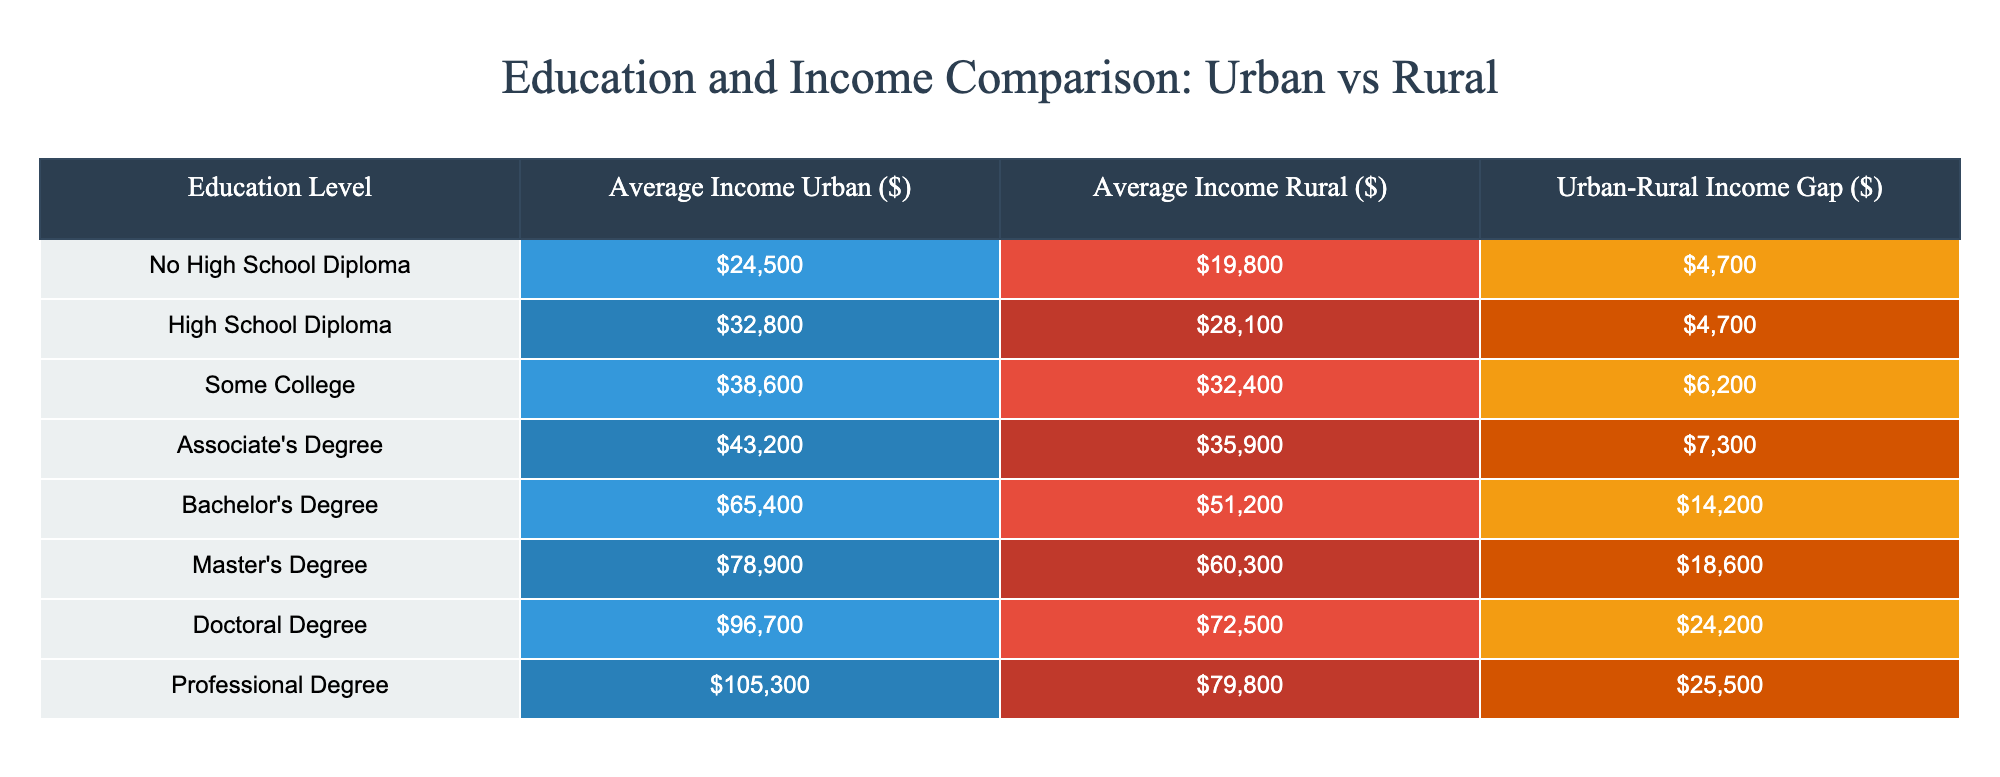What is the average income for individuals with a Bachelor's Degree in urban areas? Referring to the table, the average income for a Bachelor's Degree in urban areas is found in the "Average Income Urban" column next to the row listing "Bachelor's Degree". This value is 65400.
Answer: 65400 What is the income gap between urban and rural areas for those with a Master's Degree? The income gap for a Master's Degree can be found in the "Urban-Rural Income Gap" column for the corresponding row. It shows that the gap is 18600.
Answer: 18600 Does the average income in rural areas surpass 30000 for individuals with a High School Diploma? Looking at the table, the average income for those with a High School Diploma in rural areas is 28100, which does not surpass 30000. Therefore, the answer is no.
Answer: No Which education level shows the highest urban-rural income gap? To find this, we can compare all the values in the "Urban-Rural Income Gap" column. The highest income gap appears in the row for "Professional Degree", with a gap of 25500.
Answer: Professional Degree What is the average urban income for individuals with some college education? According to the table, some college education has an average urban income of 38600, which is found under the "Average Income Urban" column for the corresponding row.
Answer: 38600 Is the average income for individuals with a Doctoral Degree in urban areas more than 90000? By referring to the "Average Income Urban" for Doctoral Degree in the table, we see the value is 96700, which is indeed greater than 90000. Thus, the answer is yes.
Answer: Yes What is the total rural income for individuals with an Associate's Degree and a Bachelor's Degree? To determine this, we will sum the average rural income of Associate's Degree (35900) and Bachelor's Degree (51200). The calculation is 35900 + 51200 = 87100.
Answer: 87100 How much higher is the average income for individuals with a Doctoral Degree compared to those with no high school diploma in urban areas? We can find this by subtracting the average urban income for those with no high school diploma (24500) from the average income for a Doctoral Degree (96700). The calculation is 96700 - 24500 = 72200.
Answer: 72200 Which education level has the lowest average income in rural areas, and what is that income? By analyzing the "Average Income Rural" column, we see that the lowest income is associated with "No High School Diploma", which has an average rural income of 19800.
Answer: No High School Diploma, 19800 